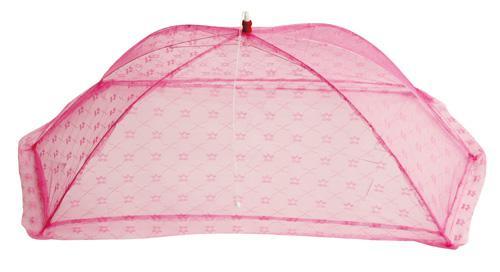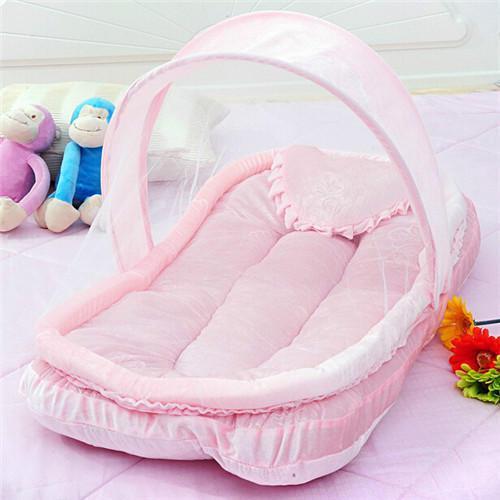The first image is the image on the left, the second image is the image on the right. Examine the images to the left and right. Is the description "In one image, the baby bed is solid pink and has a shell cover over one end." accurate? Answer yes or no. Yes. 